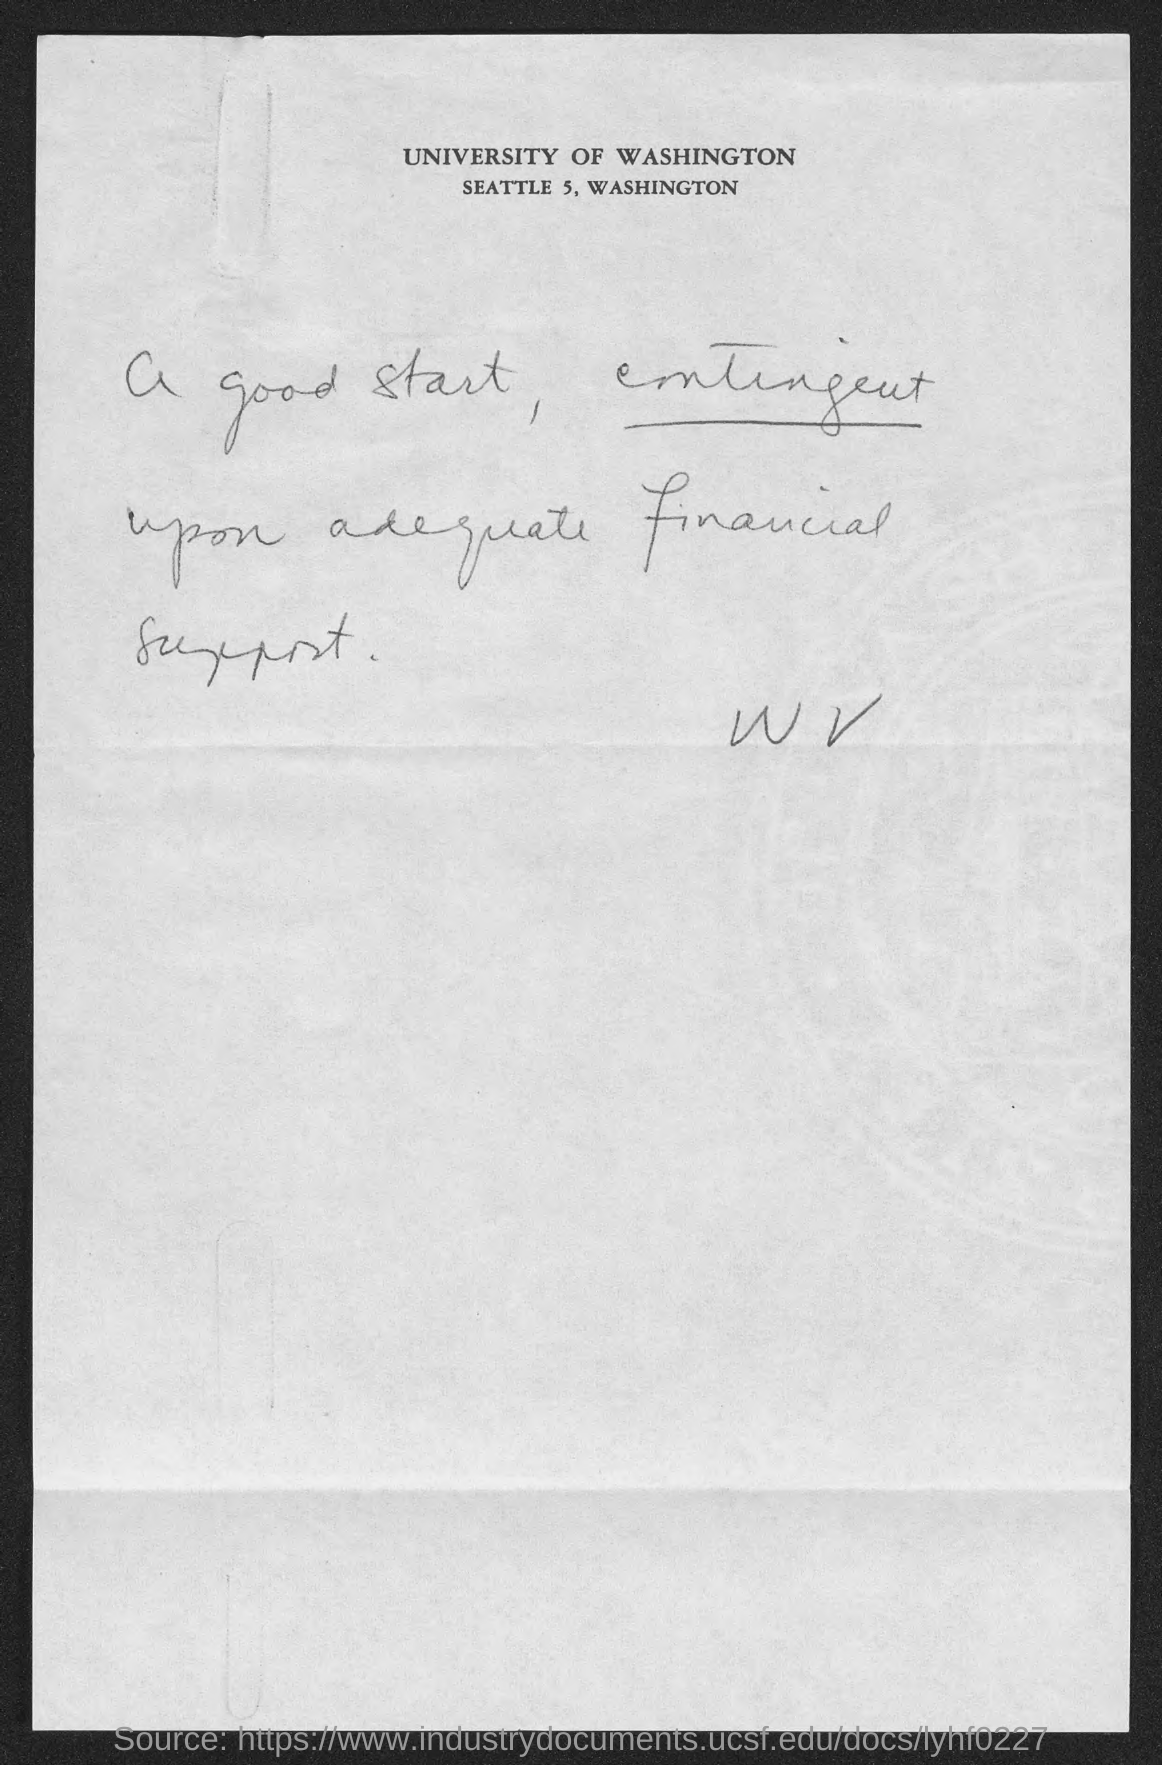Outline some significant characteristics in this image. The address of the University of Washington is located in Seattle, Washington. 